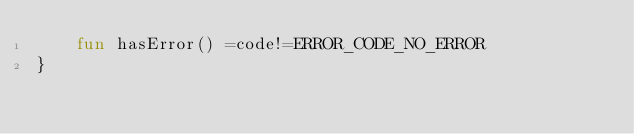Convert code to text. <code><loc_0><loc_0><loc_500><loc_500><_Kotlin_>    fun hasError() =code!=ERROR_CODE_NO_ERROR
}
</code> 